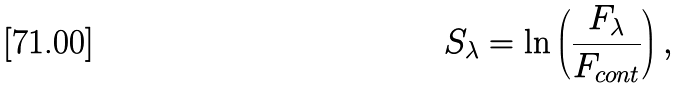Convert formula to latex. <formula><loc_0><loc_0><loc_500><loc_500>S _ { \lambda } = \ln \left ( \frac { F _ { \lambda } } { F _ { c o n t } } \right ) ,</formula> 